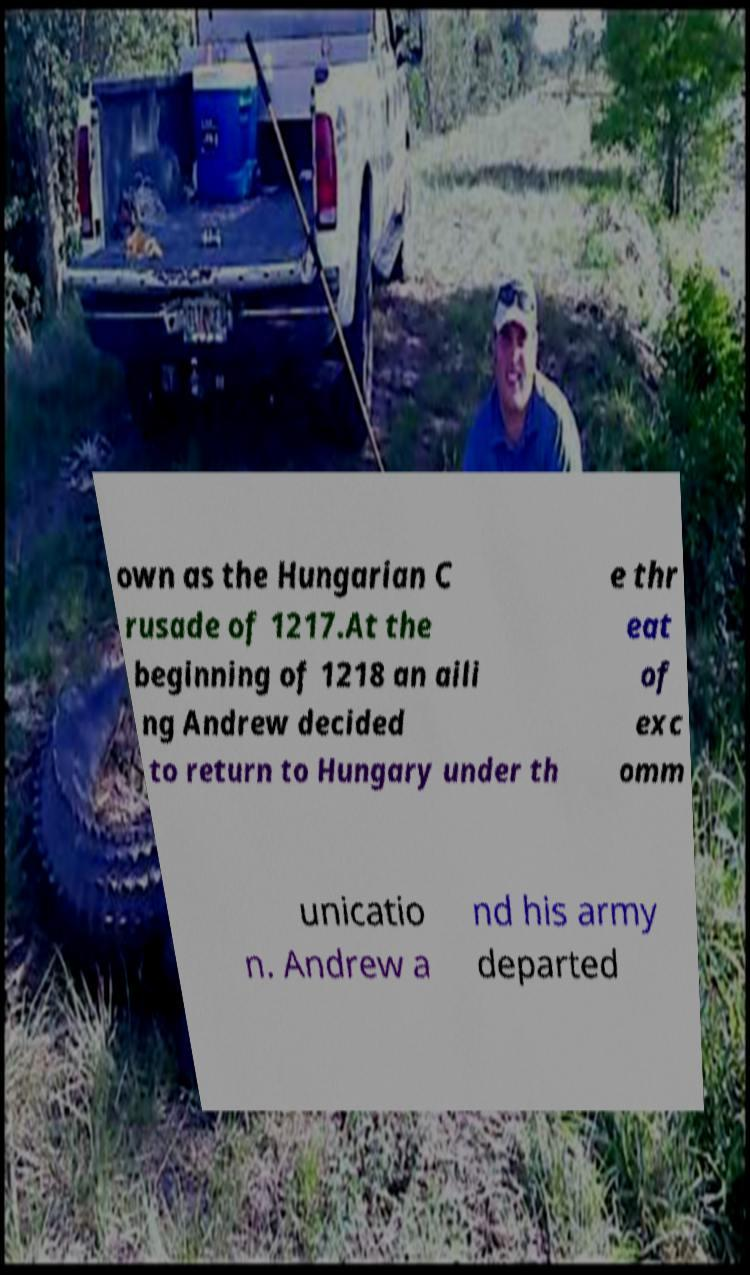For documentation purposes, I need the text within this image transcribed. Could you provide that? own as the Hungarian C rusade of 1217.At the beginning of 1218 an aili ng Andrew decided to return to Hungary under th e thr eat of exc omm unicatio n. Andrew a nd his army departed 